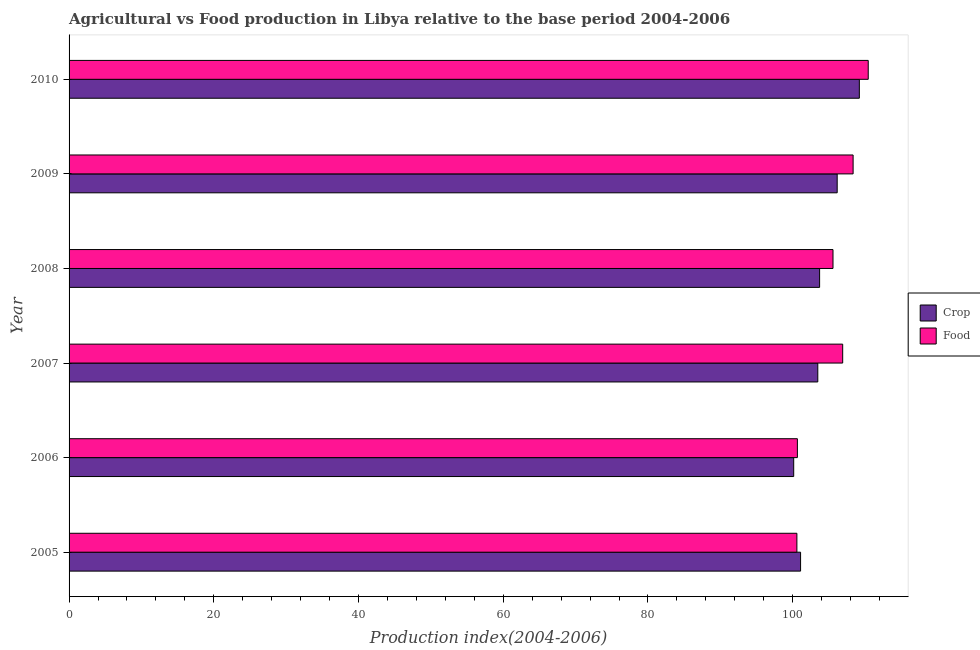How many groups of bars are there?
Provide a succinct answer. 6. What is the food production index in 2010?
Ensure brevity in your answer.  110.44. Across all years, what is the maximum crop production index?
Provide a short and direct response. 109.21. Across all years, what is the minimum crop production index?
Give a very brief answer. 100.14. In which year was the food production index maximum?
Your answer should be very brief. 2010. What is the total food production index in the graph?
Make the answer very short. 632.5. What is the difference between the food production index in 2009 and that in 2010?
Your response must be concise. -2.09. What is the difference between the crop production index in 2007 and the food production index in 2010?
Offer a terse response. -6.97. What is the average crop production index per year?
Provide a short and direct response. 103.96. What is the ratio of the crop production index in 2005 to that in 2008?
Keep it short and to the point. 0.97. What is the difference between the highest and the second highest food production index?
Offer a very short reply. 2.09. What is the difference between the highest and the lowest food production index?
Offer a terse response. 9.86. In how many years, is the food production index greater than the average food production index taken over all years?
Ensure brevity in your answer.  4. Is the sum of the crop production index in 2005 and 2010 greater than the maximum food production index across all years?
Keep it short and to the point. Yes. What does the 2nd bar from the top in 2007 represents?
Your answer should be compact. Crop. What does the 1st bar from the bottom in 2006 represents?
Your answer should be compact. Crop. Are all the bars in the graph horizontal?
Your answer should be compact. Yes. How many years are there in the graph?
Keep it short and to the point. 6. Does the graph contain any zero values?
Give a very brief answer. No. Does the graph contain grids?
Make the answer very short. No. Where does the legend appear in the graph?
Your answer should be very brief. Center right. How many legend labels are there?
Provide a short and direct response. 2. How are the legend labels stacked?
Make the answer very short. Vertical. What is the title of the graph?
Offer a very short reply. Agricultural vs Food production in Libya relative to the base period 2004-2006. Does "From human activities" appear as one of the legend labels in the graph?
Your answer should be very brief. No. What is the label or title of the X-axis?
Make the answer very short. Production index(2004-2006). What is the label or title of the Y-axis?
Your answer should be very brief. Year. What is the Production index(2004-2006) of Crop in 2005?
Your answer should be very brief. 101.09. What is the Production index(2004-2006) of Food in 2005?
Provide a short and direct response. 100.58. What is the Production index(2004-2006) of Crop in 2006?
Offer a very short reply. 100.14. What is the Production index(2004-2006) in Food in 2006?
Keep it short and to the point. 100.65. What is the Production index(2004-2006) of Crop in 2007?
Provide a succinct answer. 103.47. What is the Production index(2004-2006) in Food in 2007?
Make the answer very short. 106.91. What is the Production index(2004-2006) in Crop in 2008?
Offer a terse response. 103.72. What is the Production index(2004-2006) in Food in 2008?
Your answer should be very brief. 105.57. What is the Production index(2004-2006) in Crop in 2009?
Offer a terse response. 106.15. What is the Production index(2004-2006) in Food in 2009?
Make the answer very short. 108.35. What is the Production index(2004-2006) of Crop in 2010?
Ensure brevity in your answer.  109.21. What is the Production index(2004-2006) of Food in 2010?
Ensure brevity in your answer.  110.44. Across all years, what is the maximum Production index(2004-2006) in Crop?
Provide a succinct answer. 109.21. Across all years, what is the maximum Production index(2004-2006) of Food?
Give a very brief answer. 110.44. Across all years, what is the minimum Production index(2004-2006) of Crop?
Your answer should be compact. 100.14. Across all years, what is the minimum Production index(2004-2006) in Food?
Your answer should be compact. 100.58. What is the total Production index(2004-2006) of Crop in the graph?
Your answer should be very brief. 623.78. What is the total Production index(2004-2006) of Food in the graph?
Offer a terse response. 632.5. What is the difference between the Production index(2004-2006) in Crop in 2005 and that in 2006?
Your response must be concise. 0.95. What is the difference between the Production index(2004-2006) in Food in 2005 and that in 2006?
Provide a succinct answer. -0.07. What is the difference between the Production index(2004-2006) in Crop in 2005 and that in 2007?
Your answer should be very brief. -2.38. What is the difference between the Production index(2004-2006) of Food in 2005 and that in 2007?
Offer a terse response. -6.33. What is the difference between the Production index(2004-2006) of Crop in 2005 and that in 2008?
Your answer should be compact. -2.63. What is the difference between the Production index(2004-2006) of Food in 2005 and that in 2008?
Your answer should be compact. -4.99. What is the difference between the Production index(2004-2006) in Crop in 2005 and that in 2009?
Keep it short and to the point. -5.06. What is the difference between the Production index(2004-2006) in Food in 2005 and that in 2009?
Offer a very short reply. -7.77. What is the difference between the Production index(2004-2006) of Crop in 2005 and that in 2010?
Your response must be concise. -8.12. What is the difference between the Production index(2004-2006) in Food in 2005 and that in 2010?
Provide a succinct answer. -9.86. What is the difference between the Production index(2004-2006) of Crop in 2006 and that in 2007?
Provide a succinct answer. -3.33. What is the difference between the Production index(2004-2006) in Food in 2006 and that in 2007?
Your answer should be compact. -6.26. What is the difference between the Production index(2004-2006) of Crop in 2006 and that in 2008?
Offer a terse response. -3.58. What is the difference between the Production index(2004-2006) in Food in 2006 and that in 2008?
Ensure brevity in your answer.  -4.92. What is the difference between the Production index(2004-2006) in Crop in 2006 and that in 2009?
Offer a terse response. -6.01. What is the difference between the Production index(2004-2006) in Crop in 2006 and that in 2010?
Your answer should be compact. -9.07. What is the difference between the Production index(2004-2006) of Food in 2006 and that in 2010?
Ensure brevity in your answer.  -9.79. What is the difference between the Production index(2004-2006) in Food in 2007 and that in 2008?
Give a very brief answer. 1.34. What is the difference between the Production index(2004-2006) of Crop in 2007 and that in 2009?
Provide a succinct answer. -2.68. What is the difference between the Production index(2004-2006) in Food in 2007 and that in 2009?
Your response must be concise. -1.44. What is the difference between the Production index(2004-2006) in Crop in 2007 and that in 2010?
Offer a terse response. -5.74. What is the difference between the Production index(2004-2006) of Food in 2007 and that in 2010?
Provide a succinct answer. -3.53. What is the difference between the Production index(2004-2006) in Crop in 2008 and that in 2009?
Provide a short and direct response. -2.43. What is the difference between the Production index(2004-2006) in Food in 2008 and that in 2009?
Keep it short and to the point. -2.78. What is the difference between the Production index(2004-2006) in Crop in 2008 and that in 2010?
Your answer should be compact. -5.49. What is the difference between the Production index(2004-2006) in Food in 2008 and that in 2010?
Offer a very short reply. -4.87. What is the difference between the Production index(2004-2006) of Crop in 2009 and that in 2010?
Ensure brevity in your answer.  -3.06. What is the difference between the Production index(2004-2006) in Food in 2009 and that in 2010?
Ensure brevity in your answer.  -2.09. What is the difference between the Production index(2004-2006) in Crop in 2005 and the Production index(2004-2006) in Food in 2006?
Offer a very short reply. 0.44. What is the difference between the Production index(2004-2006) of Crop in 2005 and the Production index(2004-2006) of Food in 2007?
Offer a terse response. -5.82. What is the difference between the Production index(2004-2006) in Crop in 2005 and the Production index(2004-2006) in Food in 2008?
Your answer should be very brief. -4.48. What is the difference between the Production index(2004-2006) of Crop in 2005 and the Production index(2004-2006) of Food in 2009?
Keep it short and to the point. -7.26. What is the difference between the Production index(2004-2006) of Crop in 2005 and the Production index(2004-2006) of Food in 2010?
Make the answer very short. -9.35. What is the difference between the Production index(2004-2006) of Crop in 2006 and the Production index(2004-2006) of Food in 2007?
Your answer should be compact. -6.77. What is the difference between the Production index(2004-2006) in Crop in 2006 and the Production index(2004-2006) in Food in 2008?
Provide a short and direct response. -5.43. What is the difference between the Production index(2004-2006) in Crop in 2006 and the Production index(2004-2006) in Food in 2009?
Keep it short and to the point. -8.21. What is the difference between the Production index(2004-2006) of Crop in 2007 and the Production index(2004-2006) of Food in 2009?
Provide a short and direct response. -4.88. What is the difference between the Production index(2004-2006) of Crop in 2007 and the Production index(2004-2006) of Food in 2010?
Your answer should be very brief. -6.97. What is the difference between the Production index(2004-2006) of Crop in 2008 and the Production index(2004-2006) of Food in 2009?
Offer a terse response. -4.63. What is the difference between the Production index(2004-2006) of Crop in 2008 and the Production index(2004-2006) of Food in 2010?
Your answer should be very brief. -6.72. What is the difference between the Production index(2004-2006) of Crop in 2009 and the Production index(2004-2006) of Food in 2010?
Provide a short and direct response. -4.29. What is the average Production index(2004-2006) of Crop per year?
Offer a terse response. 103.96. What is the average Production index(2004-2006) in Food per year?
Ensure brevity in your answer.  105.42. In the year 2005, what is the difference between the Production index(2004-2006) in Crop and Production index(2004-2006) in Food?
Give a very brief answer. 0.51. In the year 2006, what is the difference between the Production index(2004-2006) of Crop and Production index(2004-2006) of Food?
Offer a terse response. -0.51. In the year 2007, what is the difference between the Production index(2004-2006) of Crop and Production index(2004-2006) of Food?
Provide a short and direct response. -3.44. In the year 2008, what is the difference between the Production index(2004-2006) in Crop and Production index(2004-2006) in Food?
Offer a terse response. -1.85. In the year 2010, what is the difference between the Production index(2004-2006) of Crop and Production index(2004-2006) of Food?
Provide a succinct answer. -1.23. What is the ratio of the Production index(2004-2006) of Crop in 2005 to that in 2006?
Your answer should be compact. 1.01. What is the ratio of the Production index(2004-2006) in Crop in 2005 to that in 2007?
Your response must be concise. 0.98. What is the ratio of the Production index(2004-2006) of Food in 2005 to that in 2007?
Your answer should be compact. 0.94. What is the ratio of the Production index(2004-2006) in Crop in 2005 to that in 2008?
Your response must be concise. 0.97. What is the ratio of the Production index(2004-2006) of Food in 2005 to that in 2008?
Provide a short and direct response. 0.95. What is the ratio of the Production index(2004-2006) of Crop in 2005 to that in 2009?
Your response must be concise. 0.95. What is the ratio of the Production index(2004-2006) of Food in 2005 to that in 2009?
Offer a very short reply. 0.93. What is the ratio of the Production index(2004-2006) in Crop in 2005 to that in 2010?
Provide a short and direct response. 0.93. What is the ratio of the Production index(2004-2006) in Food in 2005 to that in 2010?
Your response must be concise. 0.91. What is the ratio of the Production index(2004-2006) of Crop in 2006 to that in 2007?
Offer a terse response. 0.97. What is the ratio of the Production index(2004-2006) of Food in 2006 to that in 2007?
Offer a very short reply. 0.94. What is the ratio of the Production index(2004-2006) in Crop in 2006 to that in 2008?
Your response must be concise. 0.97. What is the ratio of the Production index(2004-2006) of Food in 2006 to that in 2008?
Your answer should be very brief. 0.95. What is the ratio of the Production index(2004-2006) in Crop in 2006 to that in 2009?
Your answer should be compact. 0.94. What is the ratio of the Production index(2004-2006) in Food in 2006 to that in 2009?
Provide a succinct answer. 0.93. What is the ratio of the Production index(2004-2006) in Crop in 2006 to that in 2010?
Ensure brevity in your answer.  0.92. What is the ratio of the Production index(2004-2006) in Food in 2006 to that in 2010?
Your response must be concise. 0.91. What is the ratio of the Production index(2004-2006) of Food in 2007 to that in 2008?
Offer a terse response. 1.01. What is the ratio of the Production index(2004-2006) of Crop in 2007 to that in 2009?
Your answer should be compact. 0.97. What is the ratio of the Production index(2004-2006) of Food in 2007 to that in 2009?
Ensure brevity in your answer.  0.99. What is the ratio of the Production index(2004-2006) of Food in 2007 to that in 2010?
Provide a short and direct response. 0.97. What is the ratio of the Production index(2004-2006) of Crop in 2008 to that in 2009?
Provide a succinct answer. 0.98. What is the ratio of the Production index(2004-2006) of Food in 2008 to that in 2009?
Keep it short and to the point. 0.97. What is the ratio of the Production index(2004-2006) in Crop in 2008 to that in 2010?
Provide a short and direct response. 0.95. What is the ratio of the Production index(2004-2006) of Food in 2008 to that in 2010?
Your answer should be very brief. 0.96. What is the ratio of the Production index(2004-2006) in Food in 2009 to that in 2010?
Make the answer very short. 0.98. What is the difference between the highest and the second highest Production index(2004-2006) in Crop?
Offer a terse response. 3.06. What is the difference between the highest and the second highest Production index(2004-2006) of Food?
Provide a succinct answer. 2.09. What is the difference between the highest and the lowest Production index(2004-2006) of Crop?
Your response must be concise. 9.07. What is the difference between the highest and the lowest Production index(2004-2006) in Food?
Offer a very short reply. 9.86. 